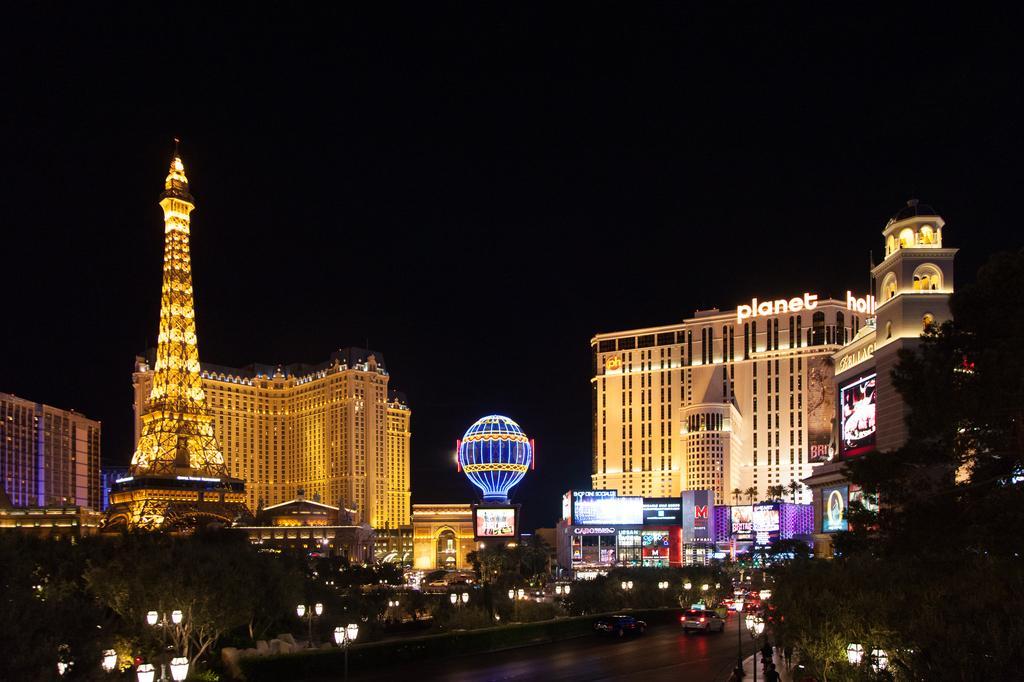Could you give a brief overview of what you see in this image? There are vehicles on the road. There are light poles and trees. There is paris hotel at the left and there are buildings at the back. It's the night time and there is a clear sky. 